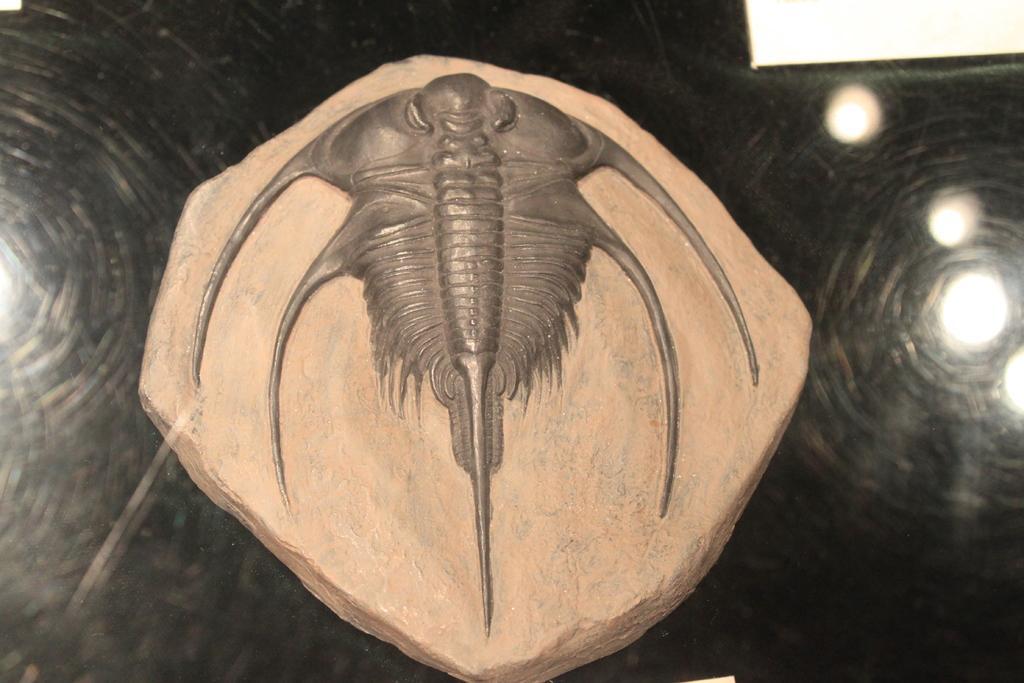Describe this image in one or two sentences. In this image I can see a stone craft, lights and a glass. This image is taken may be during night. 